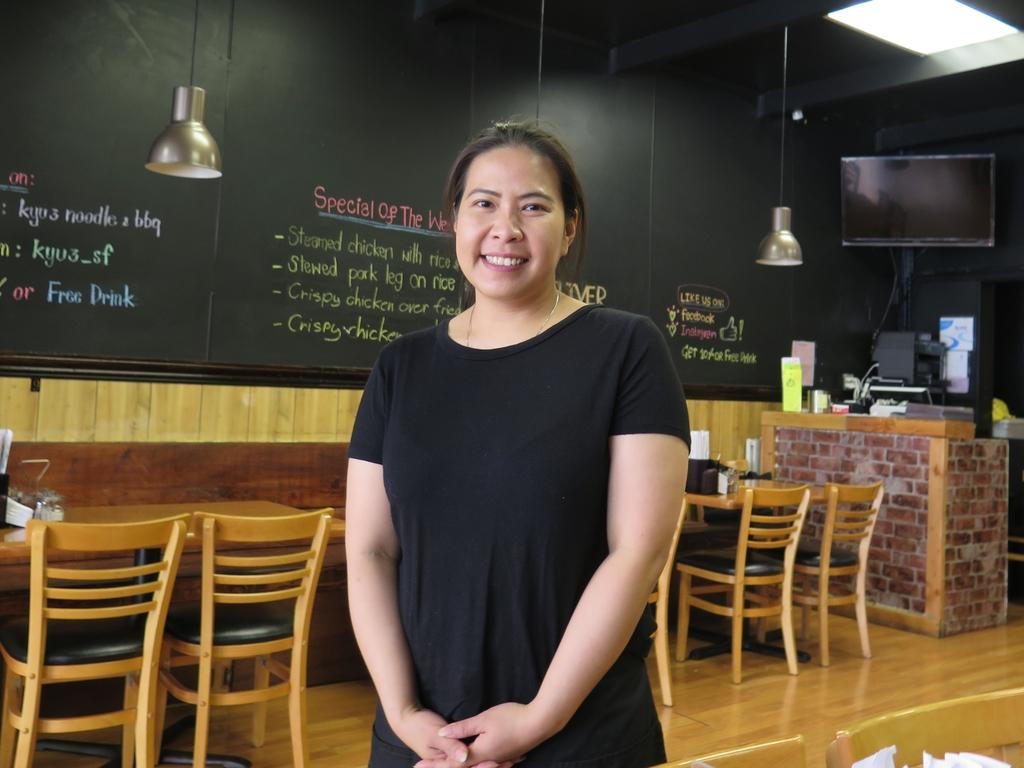Who is present in the image? There is a woman in the image. What is the woman doing in the image? The woman is standing and smiling in the image. What type of furniture can be seen in the image? There are tables and chairs in the image. What can be seen in the background of the image? There is a television, lamps, and some objects visible in the background of the image. How many lizards are crawling on the woman's shoulder in the image? There are no lizards present in the image. What type of pet is sitting on the chair next to the woman in the image? There is no pet visible in the image. 